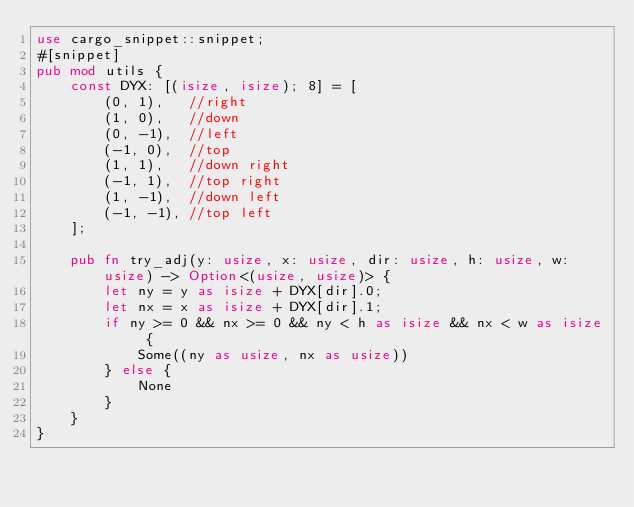Convert code to text. <code><loc_0><loc_0><loc_500><loc_500><_Rust_>use cargo_snippet::snippet;
#[snippet]
pub mod utils {
    const DYX: [(isize, isize); 8] = [
        (0, 1),   //right
        (1, 0),   //down
        (0, -1),  //left
        (-1, 0),  //top
        (1, 1),   //down right
        (-1, 1),  //top right
        (1, -1),  //down left
        (-1, -1), //top left
    ];

    pub fn try_adj(y: usize, x: usize, dir: usize, h: usize, w: usize) -> Option<(usize, usize)> {
        let ny = y as isize + DYX[dir].0;
        let nx = x as isize + DYX[dir].1;
        if ny >= 0 && nx >= 0 && ny < h as isize && nx < w as isize {
            Some((ny as usize, nx as usize))
        } else {
            None
        }
    }
}
</code> 